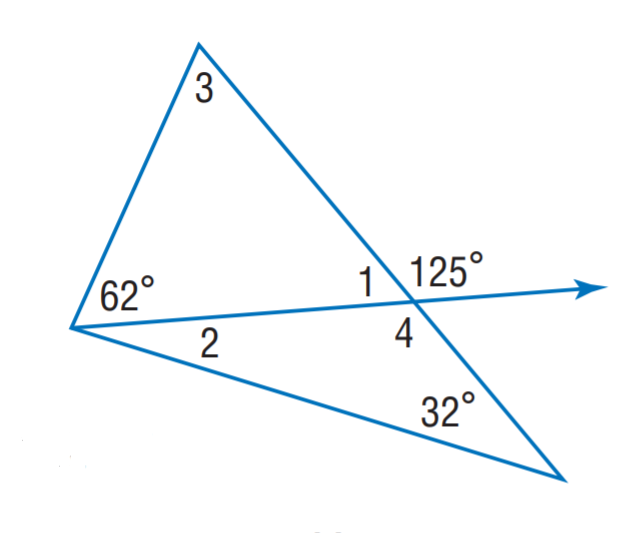Answer the mathemtical geometry problem and directly provide the correct option letter.
Question: Find m \angle 1.
Choices: A: 23 B: 55 C: 63 D: 125 B 